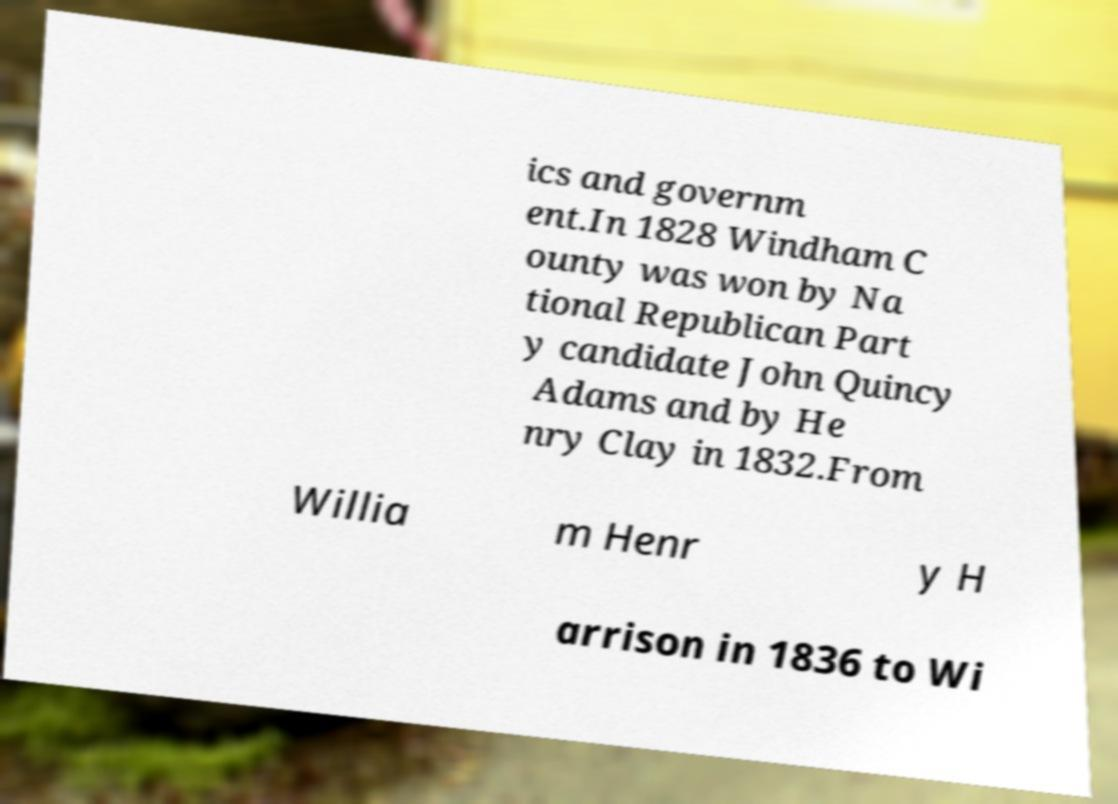What messages or text are displayed in this image? I need them in a readable, typed format. ics and governm ent.In 1828 Windham C ounty was won by Na tional Republican Part y candidate John Quincy Adams and by He nry Clay in 1832.From Willia m Henr y H arrison in 1836 to Wi 